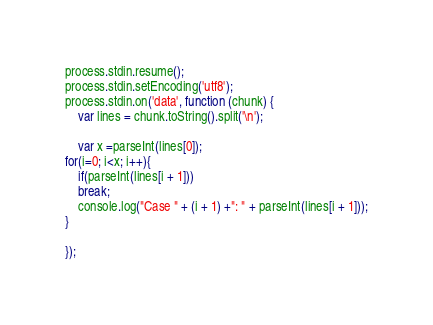<code> <loc_0><loc_0><loc_500><loc_500><_JavaScript_>process.stdin.resume();
process.stdin.setEncoding('utf8');
process.stdin.on('data', function (chunk) {
    var lines = chunk.toString().split('\n');

    var x =parseInt(lines[0]);
for(i=0; i<x; i++){
    if(parseInt(lines[i + 1]))
    break;
    console.log("Case " + (i + 1) +": " + parseInt(lines[i + 1]));
}

});</code> 